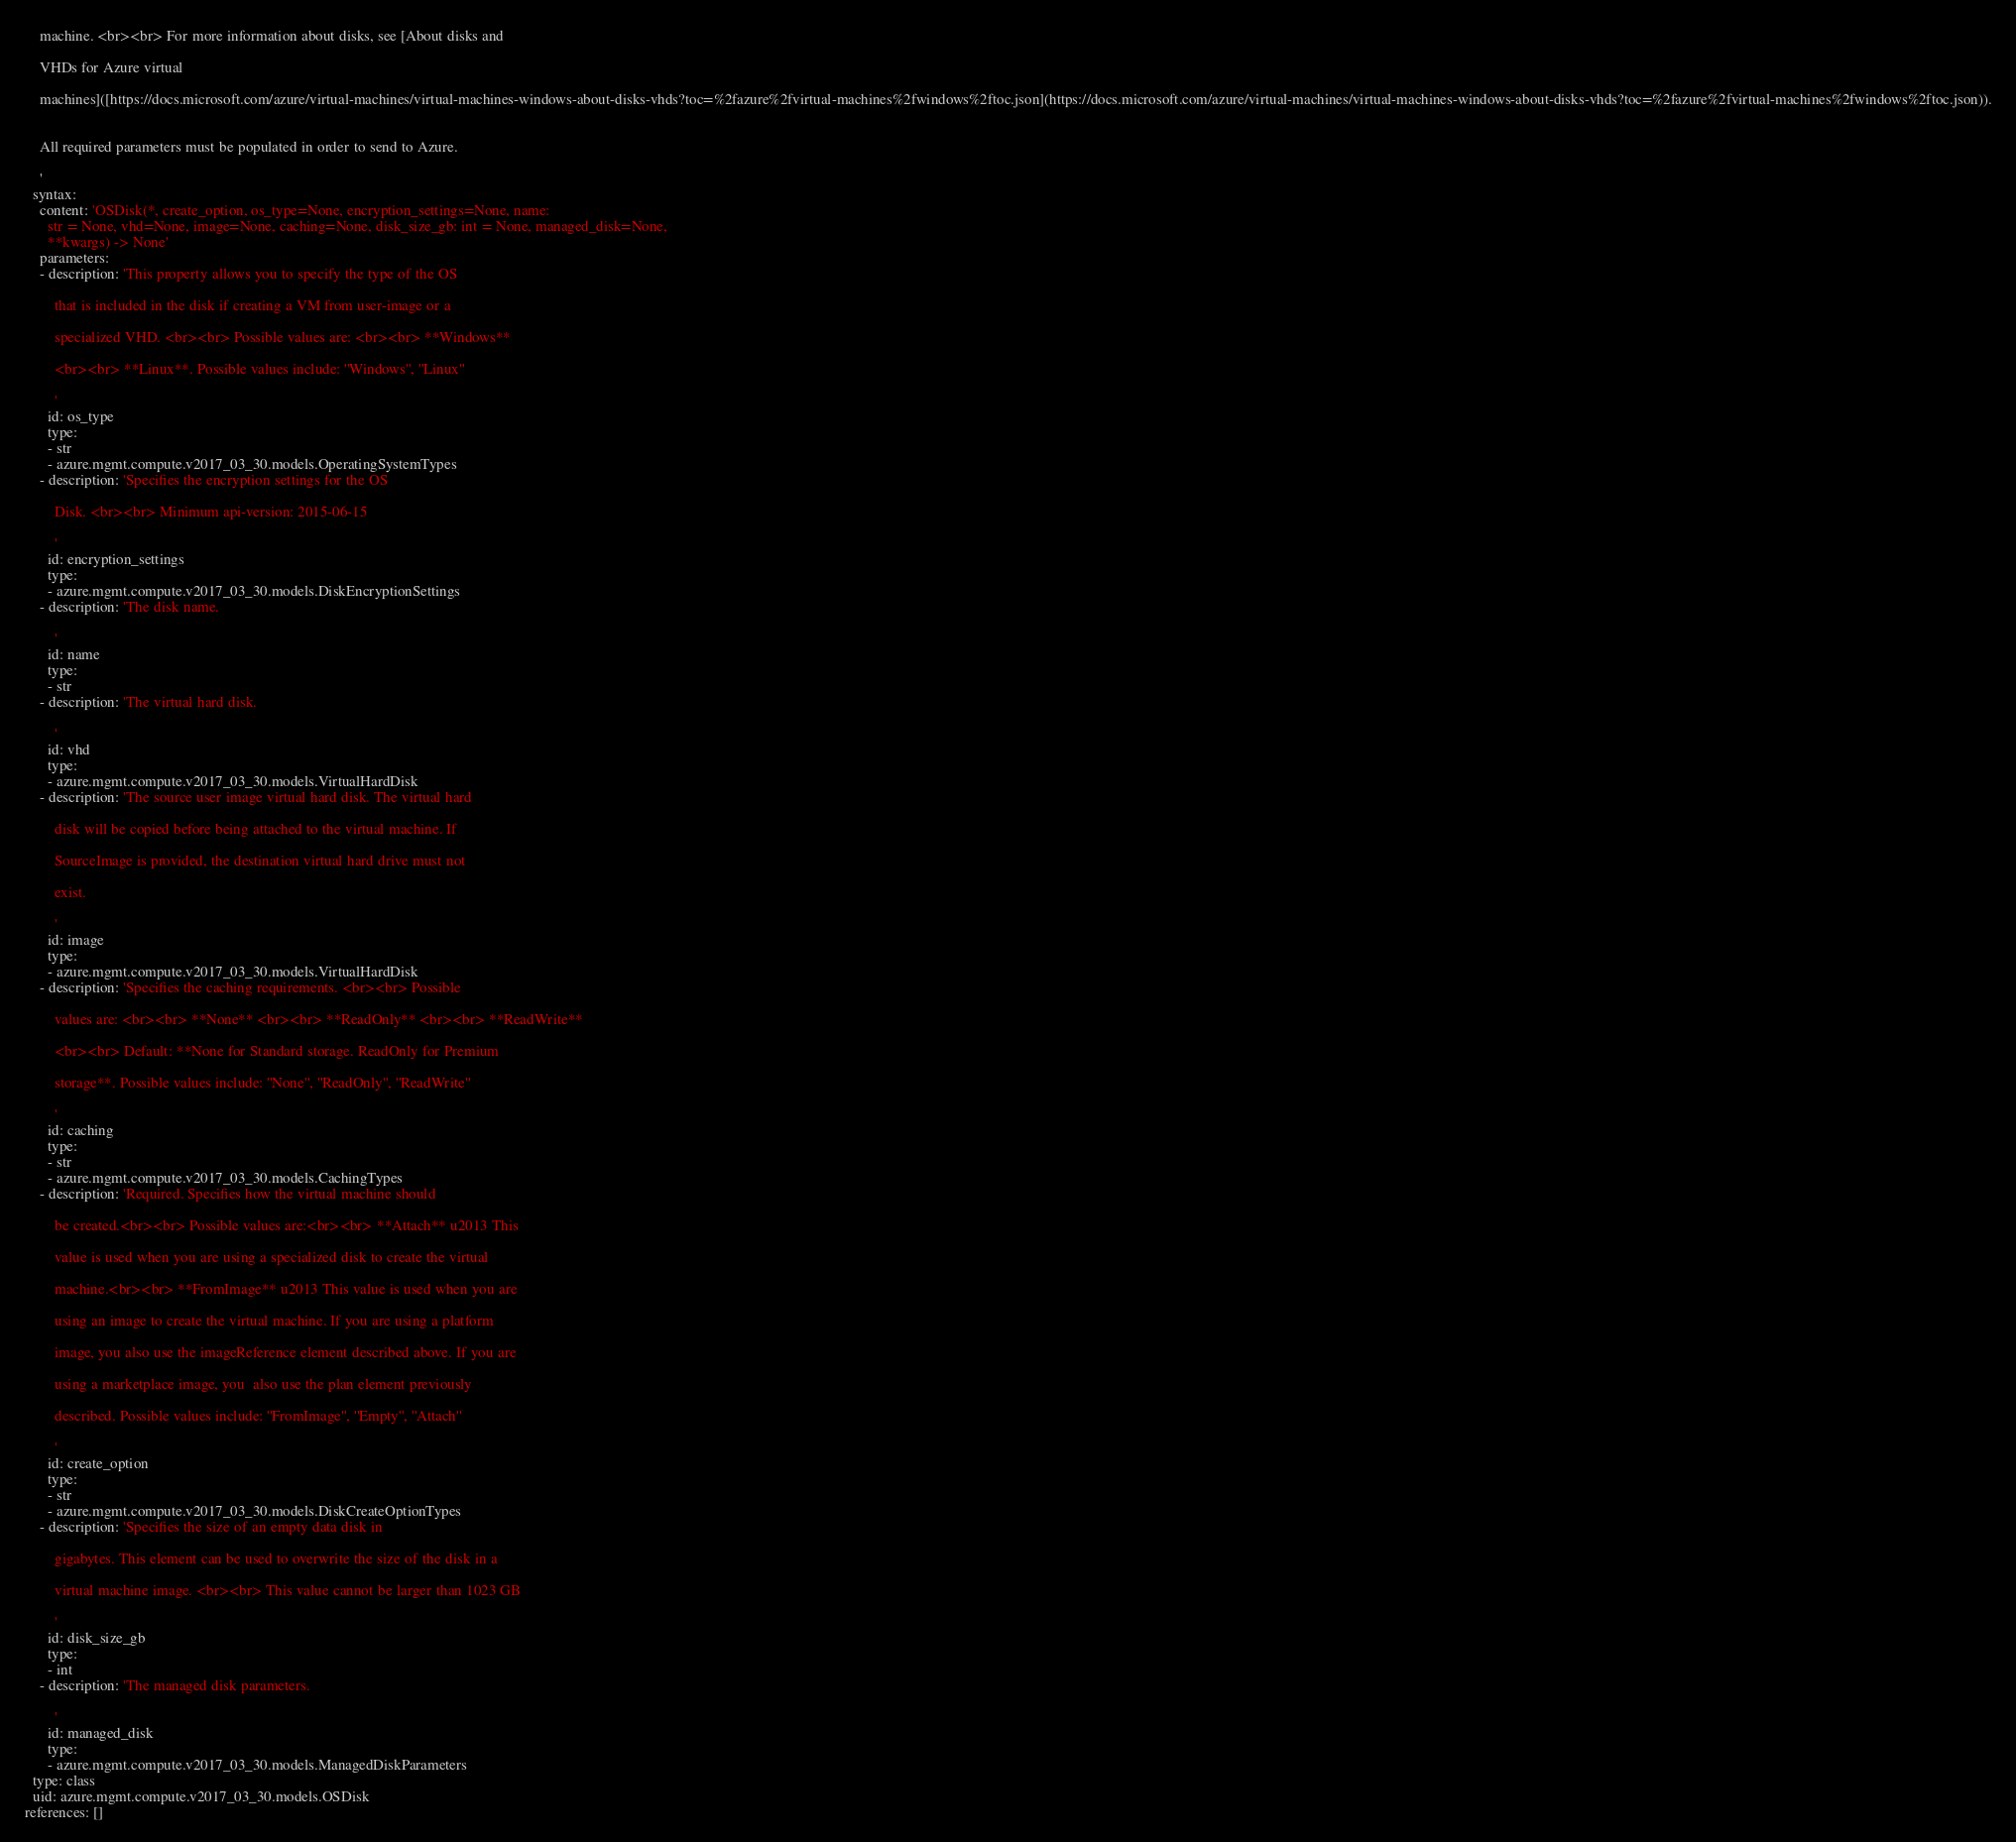Convert code to text. <code><loc_0><loc_0><loc_500><loc_500><_YAML_>    machine. <br><br> For more information about disks, see [About disks and

    VHDs for Azure virtual

    machines]([https://docs.microsoft.com/azure/virtual-machines/virtual-machines-windows-about-disks-vhds?toc=%2fazure%2fvirtual-machines%2fwindows%2ftoc.json](https://docs.microsoft.com/azure/virtual-machines/virtual-machines-windows-about-disks-vhds?toc=%2fazure%2fvirtual-machines%2fwindows%2ftoc.json)).


    All required parameters must be populated in order to send to Azure.

    '
  syntax:
    content: 'OSDisk(*, create_option, os_type=None, encryption_settings=None, name:
      str = None, vhd=None, image=None, caching=None, disk_size_gb: int = None, managed_disk=None,
      **kwargs) -> None'
    parameters:
    - description: 'This property allows you to specify the type of the OS

        that is included in the disk if creating a VM from user-image or a

        specialized VHD. <br><br> Possible values are: <br><br> **Windows**

        <br><br> **Linux**. Possible values include: ''Windows'', ''Linux''

        '
      id: os_type
      type:
      - str
      - azure.mgmt.compute.v2017_03_30.models.OperatingSystemTypes
    - description: 'Specifies the encryption settings for the OS

        Disk. <br><br> Minimum api-version: 2015-06-15

        '
      id: encryption_settings
      type:
      - azure.mgmt.compute.v2017_03_30.models.DiskEncryptionSettings
    - description: 'The disk name.

        '
      id: name
      type:
      - str
    - description: 'The virtual hard disk.

        '
      id: vhd
      type:
      - azure.mgmt.compute.v2017_03_30.models.VirtualHardDisk
    - description: 'The source user image virtual hard disk. The virtual hard

        disk will be copied before being attached to the virtual machine. If

        SourceImage is provided, the destination virtual hard drive must not

        exist.

        '
      id: image
      type:
      - azure.mgmt.compute.v2017_03_30.models.VirtualHardDisk
    - description: 'Specifies the caching requirements. <br><br> Possible

        values are: <br><br> **None** <br><br> **ReadOnly** <br><br> **ReadWrite**

        <br><br> Default: **None for Standard storage. ReadOnly for Premium

        storage**. Possible values include: ''None'', ''ReadOnly'', ''ReadWrite''

        '
      id: caching
      type:
      - str
      - azure.mgmt.compute.v2017_03_30.models.CachingTypes
    - description: 'Required. Specifies how the virtual machine should

        be created.<br><br> Possible values are:<br><br> **Attach** u2013 This

        value is used when you are using a specialized disk to create the virtual

        machine.<br><br> **FromImage** u2013 This value is used when you are

        using an image to create the virtual machine. If you are using a platform

        image, you also use the imageReference element described above. If you are

        using a marketplace image, you  also use the plan element previously

        described. Possible values include: ''FromImage'', ''Empty'', ''Attach''

        '
      id: create_option
      type:
      - str
      - azure.mgmt.compute.v2017_03_30.models.DiskCreateOptionTypes
    - description: 'Specifies the size of an empty data disk in

        gigabytes. This element can be used to overwrite the size of the disk in a

        virtual machine image. <br><br> This value cannot be larger than 1023 GB

        '
      id: disk_size_gb
      type:
      - int
    - description: 'The managed disk parameters.

        '
      id: managed_disk
      type:
      - azure.mgmt.compute.v2017_03_30.models.ManagedDiskParameters
  type: class
  uid: azure.mgmt.compute.v2017_03_30.models.OSDisk
references: []
</code> 